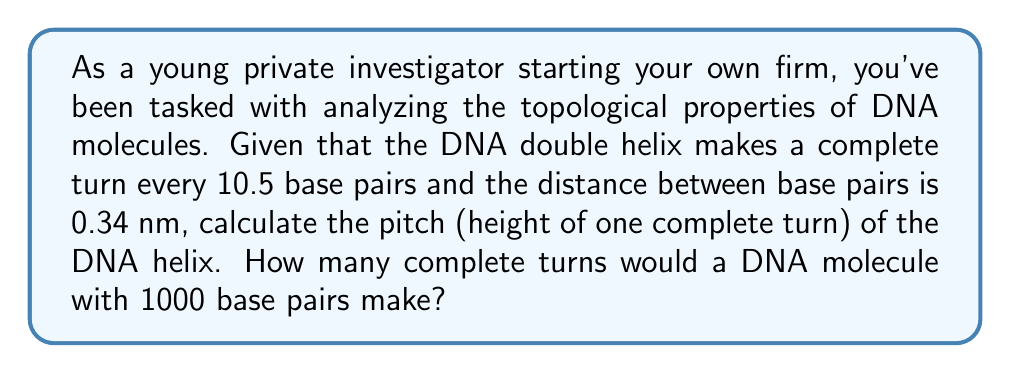What is the answer to this math problem? Let's approach this problem step by step:

1) First, we need to understand what pitch means in the context of a helix. The pitch is the height of one complete turn of the helix.

2) We're given two important pieces of information:
   - One complete turn occurs every 10.5 base pairs
   - The distance between base pairs is 0.34 nm

3) To calculate the pitch, we need to find out how much height is covered in 10.5 base pairs:

   $$ \text{Pitch} = 10.5 \times 0.34 \text{ nm} = 3.57 \text{ nm} $$

4) Now, for the second part of the question, we need to calculate how many complete turns are in a DNA molecule with 1000 base pairs.

5) We can set up a proportion:
   $$ \frac{10.5 \text{ base pairs}}{1 \text{ turn}} = \frac{1000 \text{ base pairs}}{x \text{ turns}} $$

6) Cross multiply and solve for x:
   $$ 10.5x = 1000 $$
   $$ x = \frac{1000}{10.5} \approx 95.24 \text{ turns} $$

7) Since we can't have a fraction of a turn in this context, we round down to the nearest whole number.

This problem relates to your work as a private investigator because understanding the structure of DNA is crucial in forensic science, which you might encounter in your investigations. The topological properties of DNA, such as its helical structure, are fundamental to its function and can be important in various analytical techniques used in forensic labs.
Answer: The pitch of the DNA helix is 3.57 nm. A DNA molecule with 1000 base pairs would make 95 complete turns. 